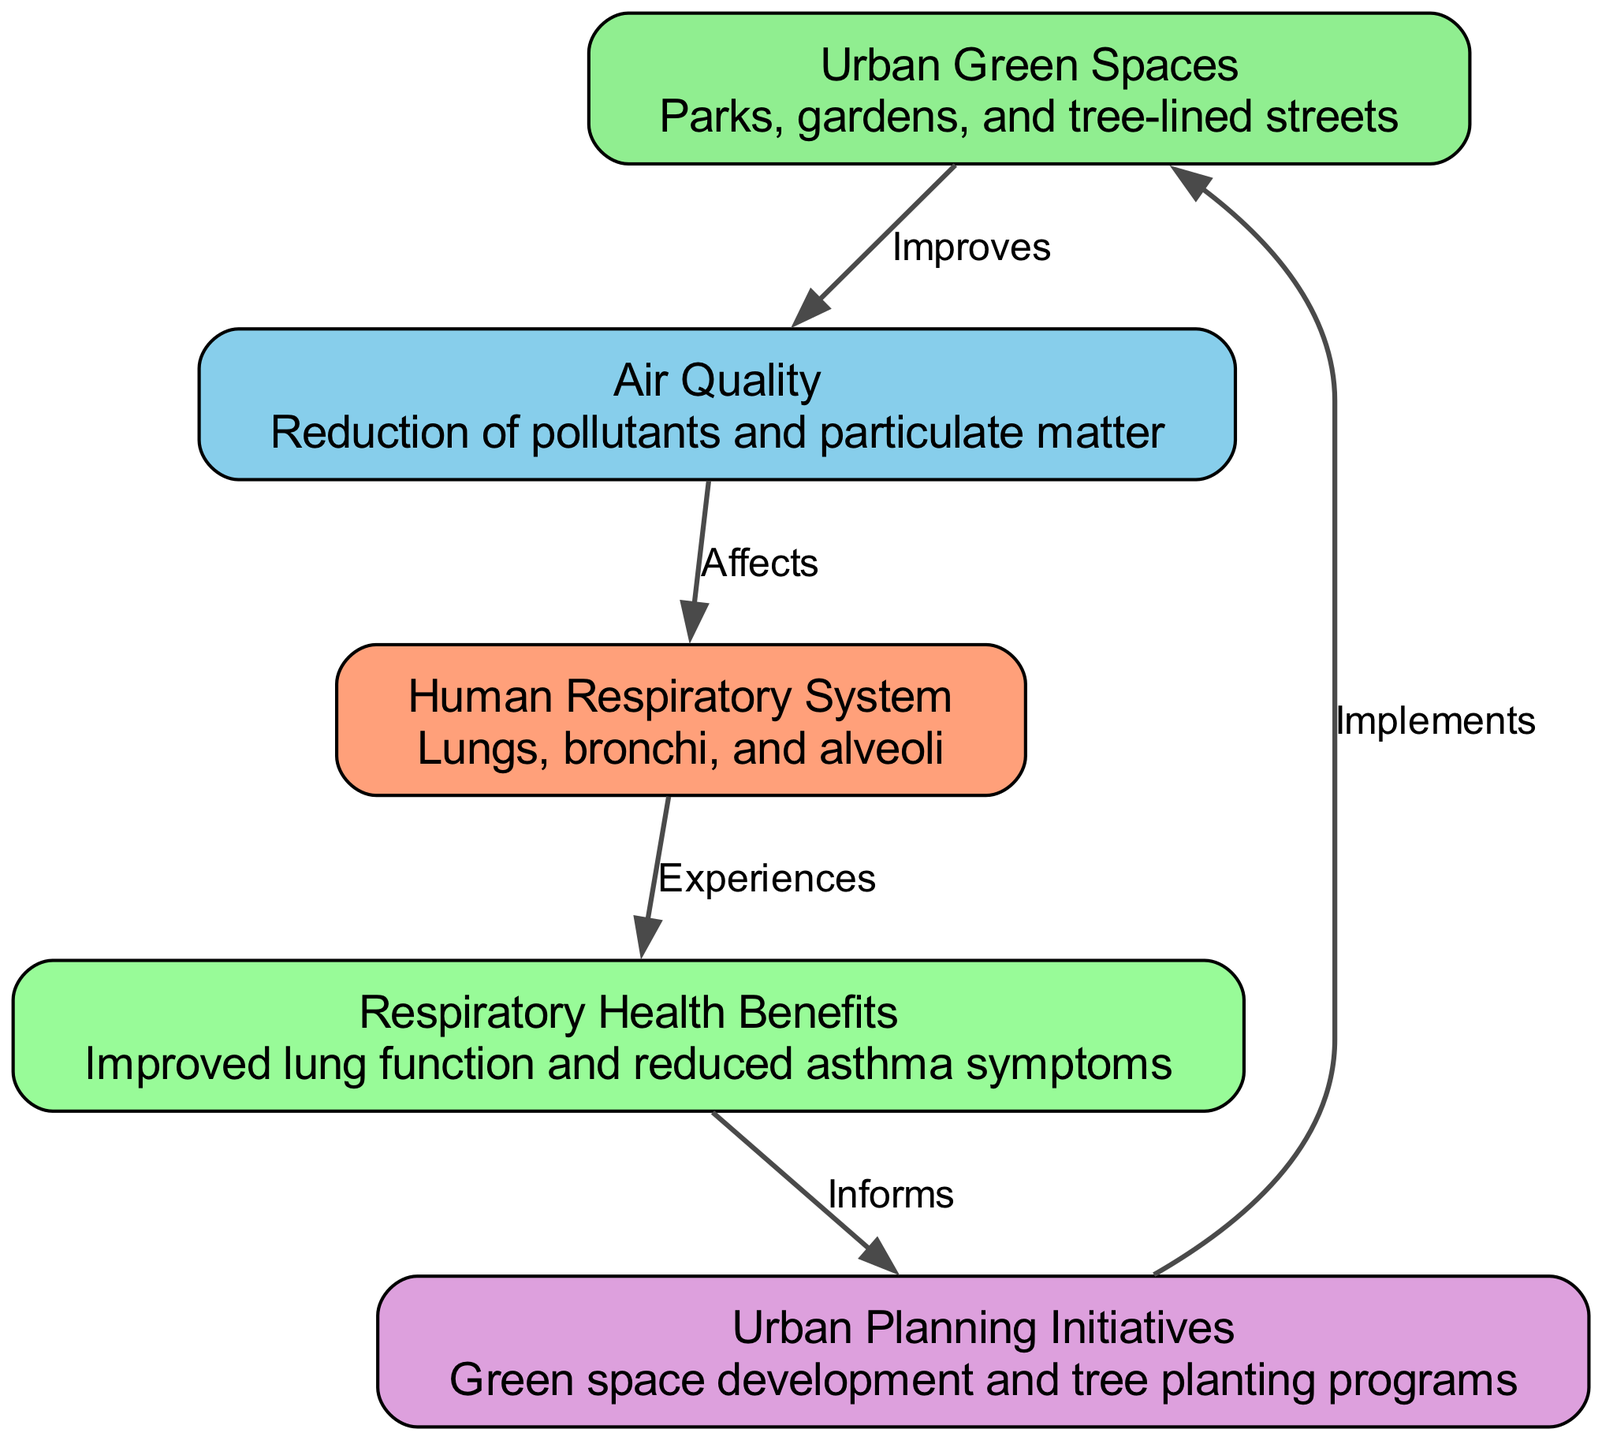What are the two main components connected by the edge labeled "Improves"? The edge labeled "Improves" connects "Urban Green Spaces" and "Air Quality," indicating that urban green spaces have a positive effect on air quality.
Answer: Urban Green Spaces, Air Quality How many nodes are present in the diagram? The diagram consists of five nodes: "Urban Green Spaces," "Air Quality," "Human Respiratory System," "Respiratory Health Benefits," and "Urban Planning Initiatives."
Answer: 5 What label describes the effect of "Air Quality" on the "Human Respiratory System"? The effect of "Air Quality" on the "Human Respiratory System" is illustrated by the edge labeled "Affects," indicating that air quality directly impacts respiratory health.
Answer: Affects Which node informs urban planning? The node labeled "Respiratory Health Benefits" is the one that informs urban planning, suggesting that understanding health benefits helps guide urban development initiatives.
Answer: Respiratory Health Benefits What is the relationship between "Urban Planning Initiatives" and "Urban Green Spaces"? The relationship is shown by the edge labeled "Implements," indicating that urban planning initiatives put into action the development of urban green spaces.
Answer: Implements What impact do urban green spaces have on health benefits? Urban green spaces lead to improved respiratory health benefits, as demonstrated by the flow from "Urban Green Spaces" to "Air Quality" to "Respiratory Health Benefits."
Answer: Improved lung function and reduced asthma symptoms Which node has the description that includes "Reduction of pollutants and particulate matter"? The description that includes "Reduction of pollutants and particulate matter" belongs to the "Air Quality" node, emphasizing the clean air contribution of urban green spaces.
Answer: Air Quality What is the concluding effect of "Respiratory System" according to the diagram? The concluding effect is that the "Respiratory System" experiences health improvements, specifically improved lung function and reduced asthma symptoms, as shown by the flow to "Respiratory Health Benefits."
Answer: Experiences 